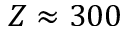<formula> <loc_0><loc_0><loc_500><loc_500>Z \approx 3 0 0</formula> 